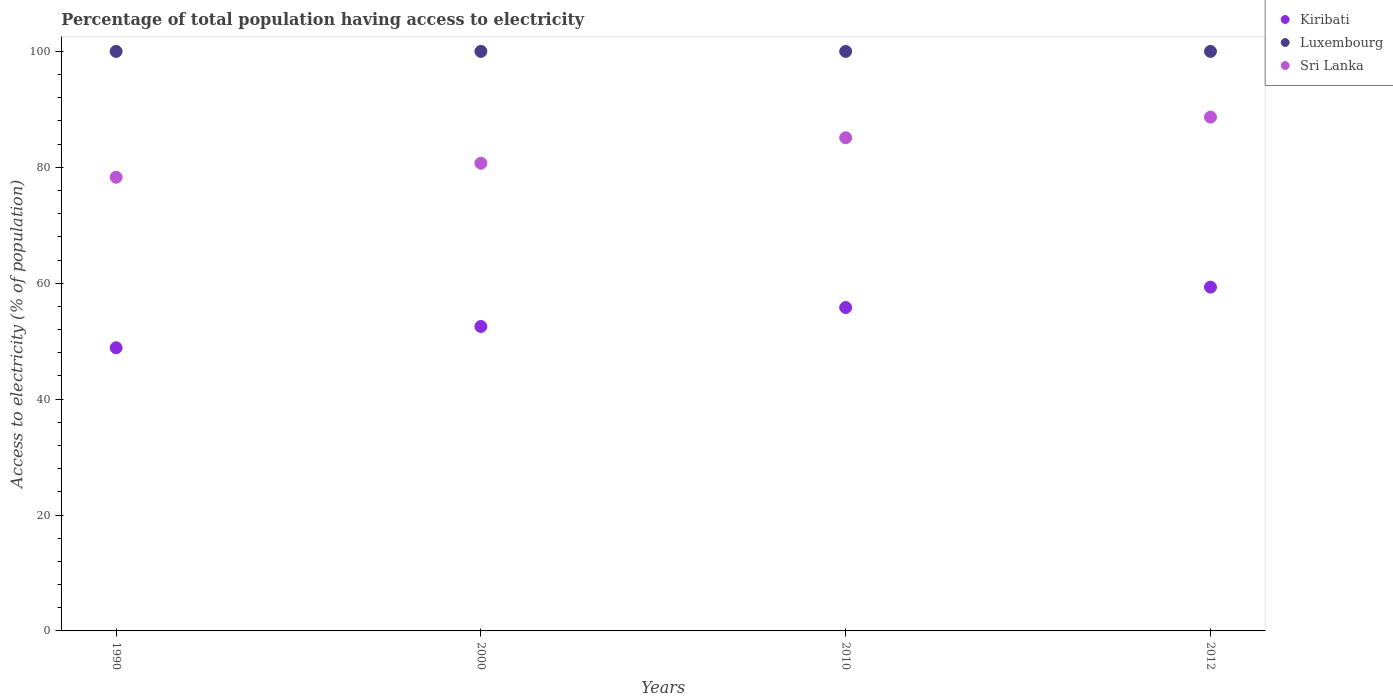What is the percentage of population that have access to electricity in Sri Lanka in 1990?
Your response must be concise. 78.29. Across all years, what is the maximum percentage of population that have access to electricity in Sri Lanka?
Provide a succinct answer. 88.66. Across all years, what is the minimum percentage of population that have access to electricity in Kiribati?
Keep it short and to the point. 48.86. In which year was the percentage of population that have access to electricity in Kiribati maximum?
Give a very brief answer. 2012. In which year was the percentage of population that have access to electricity in Sri Lanka minimum?
Ensure brevity in your answer.  1990. What is the total percentage of population that have access to electricity in Luxembourg in the graph?
Offer a very short reply. 400. What is the difference between the percentage of population that have access to electricity in Sri Lanka in 2000 and that in 2012?
Your answer should be compact. -7.96. What is the difference between the percentage of population that have access to electricity in Luxembourg in 2000 and the percentage of population that have access to electricity in Kiribati in 2010?
Make the answer very short. 44.2. In the year 2010, what is the difference between the percentage of population that have access to electricity in Sri Lanka and percentage of population that have access to electricity in Luxembourg?
Your response must be concise. -14.9. What is the ratio of the percentage of population that have access to electricity in Sri Lanka in 2000 to that in 2012?
Give a very brief answer. 0.91. Is the sum of the percentage of population that have access to electricity in Sri Lanka in 2010 and 2012 greater than the maximum percentage of population that have access to electricity in Kiribati across all years?
Provide a succinct answer. Yes. Does the percentage of population that have access to electricity in Sri Lanka monotonically increase over the years?
Provide a succinct answer. Yes. Is the percentage of population that have access to electricity in Kiribati strictly less than the percentage of population that have access to electricity in Luxembourg over the years?
Your response must be concise. Yes. How many dotlines are there?
Provide a short and direct response. 3. How many years are there in the graph?
Keep it short and to the point. 4. What is the difference between two consecutive major ticks on the Y-axis?
Give a very brief answer. 20. Where does the legend appear in the graph?
Offer a terse response. Top right. How many legend labels are there?
Your answer should be compact. 3. How are the legend labels stacked?
Provide a succinct answer. Vertical. What is the title of the graph?
Your response must be concise. Percentage of total population having access to electricity. Does "Dominica" appear as one of the legend labels in the graph?
Your answer should be compact. No. What is the label or title of the Y-axis?
Offer a terse response. Access to electricity (% of population). What is the Access to electricity (% of population) of Kiribati in 1990?
Ensure brevity in your answer.  48.86. What is the Access to electricity (% of population) of Sri Lanka in 1990?
Make the answer very short. 78.29. What is the Access to electricity (% of population) of Kiribati in 2000?
Make the answer very short. 52.53. What is the Access to electricity (% of population) in Luxembourg in 2000?
Your answer should be very brief. 100. What is the Access to electricity (% of population) in Sri Lanka in 2000?
Offer a terse response. 80.7. What is the Access to electricity (% of population) of Kiribati in 2010?
Your answer should be very brief. 55.8. What is the Access to electricity (% of population) in Luxembourg in 2010?
Your answer should be compact. 100. What is the Access to electricity (% of population) in Sri Lanka in 2010?
Give a very brief answer. 85.1. What is the Access to electricity (% of population) in Kiribati in 2012?
Ensure brevity in your answer.  59.33. What is the Access to electricity (% of population) in Luxembourg in 2012?
Your answer should be very brief. 100. What is the Access to electricity (% of population) of Sri Lanka in 2012?
Provide a short and direct response. 88.66. Across all years, what is the maximum Access to electricity (% of population) in Kiribati?
Give a very brief answer. 59.33. Across all years, what is the maximum Access to electricity (% of population) in Luxembourg?
Give a very brief answer. 100. Across all years, what is the maximum Access to electricity (% of population) in Sri Lanka?
Provide a succinct answer. 88.66. Across all years, what is the minimum Access to electricity (% of population) of Kiribati?
Your answer should be compact. 48.86. Across all years, what is the minimum Access to electricity (% of population) of Sri Lanka?
Keep it short and to the point. 78.29. What is the total Access to electricity (% of population) in Kiribati in the graph?
Make the answer very short. 216.52. What is the total Access to electricity (% of population) in Sri Lanka in the graph?
Offer a terse response. 332.75. What is the difference between the Access to electricity (% of population) in Kiribati in 1990 and that in 2000?
Your answer should be very brief. -3.67. What is the difference between the Access to electricity (% of population) in Luxembourg in 1990 and that in 2000?
Provide a succinct answer. 0. What is the difference between the Access to electricity (% of population) in Sri Lanka in 1990 and that in 2000?
Keep it short and to the point. -2.41. What is the difference between the Access to electricity (% of population) of Kiribati in 1990 and that in 2010?
Give a very brief answer. -6.94. What is the difference between the Access to electricity (% of population) of Luxembourg in 1990 and that in 2010?
Your answer should be very brief. 0. What is the difference between the Access to electricity (% of population) in Sri Lanka in 1990 and that in 2010?
Offer a very short reply. -6.81. What is the difference between the Access to electricity (% of population) in Kiribati in 1990 and that in 2012?
Your response must be concise. -10.47. What is the difference between the Access to electricity (% of population) of Luxembourg in 1990 and that in 2012?
Keep it short and to the point. 0. What is the difference between the Access to electricity (% of population) in Sri Lanka in 1990 and that in 2012?
Your answer should be very brief. -10.37. What is the difference between the Access to electricity (% of population) in Kiribati in 2000 and that in 2010?
Provide a short and direct response. -3.27. What is the difference between the Access to electricity (% of population) of Kiribati in 2000 and that in 2012?
Provide a succinct answer. -6.8. What is the difference between the Access to electricity (% of population) of Luxembourg in 2000 and that in 2012?
Your answer should be compact. 0. What is the difference between the Access to electricity (% of population) in Sri Lanka in 2000 and that in 2012?
Make the answer very short. -7.96. What is the difference between the Access to electricity (% of population) of Kiribati in 2010 and that in 2012?
Give a very brief answer. -3.53. What is the difference between the Access to electricity (% of population) of Sri Lanka in 2010 and that in 2012?
Provide a succinct answer. -3.56. What is the difference between the Access to electricity (% of population) in Kiribati in 1990 and the Access to electricity (% of population) in Luxembourg in 2000?
Give a very brief answer. -51.14. What is the difference between the Access to electricity (% of population) in Kiribati in 1990 and the Access to electricity (% of population) in Sri Lanka in 2000?
Provide a succinct answer. -31.84. What is the difference between the Access to electricity (% of population) in Luxembourg in 1990 and the Access to electricity (% of population) in Sri Lanka in 2000?
Offer a very short reply. 19.3. What is the difference between the Access to electricity (% of population) in Kiribati in 1990 and the Access to electricity (% of population) in Luxembourg in 2010?
Your response must be concise. -51.14. What is the difference between the Access to electricity (% of population) in Kiribati in 1990 and the Access to electricity (% of population) in Sri Lanka in 2010?
Your answer should be compact. -36.24. What is the difference between the Access to electricity (% of population) of Luxembourg in 1990 and the Access to electricity (% of population) of Sri Lanka in 2010?
Ensure brevity in your answer.  14.9. What is the difference between the Access to electricity (% of population) of Kiribati in 1990 and the Access to electricity (% of population) of Luxembourg in 2012?
Your response must be concise. -51.14. What is the difference between the Access to electricity (% of population) of Kiribati in 1990 and the Access to electricity (% of population) of Sri Lanka in 2012?
Give a very brief answer. -39.8. What is the difference between the Access to electricity (% of population) of Luxembourg in 1990 and the Access to electricity (% of population) of Sri Lanka in 2012?
Ensure brevity in your answer.  11.34. What is the difference between the Access to electricity (% of population) in Kiribati in 2000 and the Access to electricity (% of population) in Luxembourg in 2010?
Your answer should be compact. -47.47. What is the difference between the Access to electricity (% of population) of Kiribati in 2000 and the Access to electricity (% of population) of Sri Lanka in 2010?
Your answer should be very brief. -32.57. What is the difference between the Access to electricity (% of population) in Luxembourg in 2000 and the Access to electricity (% of population) in Sri Lanka in 2010?
Offer a very short reply. 14.9. What is the difference between the Access to electricity (% of population) in Kiribati in 2000 and the Access to electricity (% of population) in Luxembourg in 2012?
Your answer should be compact. -47.47. What is the difference between the Access to electricity (% of population) of Kiribati in 2000 and the Access to electricity (% of population) of Sri Lanka in 2012?
Offer a terse response. -36.13. What is the difference between the Access to electricity (% of population) in Luxembourg in 2000 and the Access to electricity (% of population) in Sri Lanka in 2012?
Give a very brief answer. 11.34. What is the difference between the Access to electricity (% of population) of Kiribati in 2010 and the Access to electricity (% of population) of Luxembourg in 2012?
Keep it short and to the point. -44.2. What is the difference between the Access to electricity (% of population) in Kiribati in 2010 and the Access to electricity (% of population) in Sri Lanka in 2012?
Provide a short and direct response. -32.86. What is the difference between the Access to electricity (% of population) of Luxembourg in 2010 and the Access to electricity (% of population) of Sri Lanka in 2012?
Your answer should be very brief. 11.34. What is the average Access to electricity (% of population) of Kiribati per year?
Provide a short and direct response. 54.13. What is the average Access to electricity (% of population) of Sri Lanka per year?
Your answer should be compact. 83.19. In the year 1990, what is the difference between the Access to electricity (% of population) in Kiribati and Access to electricity (% of population) in Luxembourg?
Provide a succinct answer. -51.14. In the year 1990, what is the difference between the Access to electricity (% of population) in Kiribati and Access to electricity (% of population) in Sri Lanka?
Ensure brevity in your answer.  -29.43. In the year 1990, what is the difference between the Access to electricity (% of population) in Luxembourg and Access to electricity (% of population) in Sri Lanka?
Provide a succinct answer. 21.71. In the year 2000, what is the difference between the Access to electricity (% of population) in Kiribati and Access to electricity (% of population) in Luxembourg?
Your answer should be very brief. -47.47. In the year 2000, what is the difference between the Access to electricity (% of population) in Kiribati and Access to electricity (% of population) in Sri Lanka?
Offer a terse response. -28.17. In the year 2000, what is the difference between the Access to electricity (% of population) of Luxembourg and Access to electricity (% of population) of Sri Lanka?
Keep it short and to the point. 19.3. In the year 2010, what is the difference between the Access to electricity (% of population) of Kiribati and Access to electricity (% of population) of Luxembourg?
Your response must be concise. -44.2. In the year 2010, what is the difference between the Access to electricity (% of population) in Kiribati and Access to electricity (% of population) in Sri Lanka?
Offer a very short reply. -29.3. In the year 2010, what is the difference between the Access to electricity (% of population) of Luxembourg and Access to electricity (% of population) of Sri Lanka?
Your answer should be compact. 14.9. In the year 2012, what is the difference between the Access to electricity (% of population) in Kiribati and Access to electricity (% of population) in Luxembourg?
Your answer should be compact. -40.67. In the year 2012, what is the difference between the Access to electricity (% of population) of Kiribati and Access to electricity (% of population) of Sri Lanka?
Ensure brevity in your answer.  -29.33. In the year 2012, what is the difference between the Access to electricity (% of population) of Luxembourg and Access to electricity (% of population) of Sri Lanka?
Your answer should be compact. 11.34. What is the ratio of the Access to electricity (% of population) of Kiribati in 1990 to that in 2000?
Your answer should be very brief. 0.93. What is the ratio of the Access to electricity (% of population) of Luxembourg in 1990 to that in 2000?
Keep it short and to the point. 1. What is the ratio of the Access to electricity (% of population) of Sri Lanka in 1990 to that in 2000?
Make the answer very short. 0.97. What is the ratio of the Access to electricity (% of population) in Kiribati in 1990 to that in 2010?
Ensure brevity in your answer.  0.88. What is the ratio of the Access to electricity (% of population) in Luxembourg in 1990 to that in 2010?
Make the answer very short. 1. What is the ratio of the Access to electricity (% of population) of Sri Lanka in 1990 to that in 2010?
Your response must be concise. 0.92. What is the ratio of the Access to electricity (% of population) in Kiribati in 1990 to that in 2012?
Provide a succinct answer. 0.82. What is the ratio of the Access to electricity (% of population) in Sri Lanka in 1990 to that in 2012?
Your answer should be very brief. 0.88. What is the ratio of the Access to electricity (% of population) of Kiribati in 2000 to that in 2010?
Your answer should be very brief. 0.94. What is the ratio of the Access to electricity (% of population) in Sri Lanka in 2000 to that in 2010?
Provide a short and direct response. 0.95. What is the ratio of the Access to electricity (% of population) of Kiribati in 2000 to that in 2012?
Your answer should be compact. 0.89. What is the ratio of the Access to electricity (% of population) in Sri Lanka in 2000 to that in 2012?
Provide a short and direct response. 0.91. What is the ratio of the Access to electricity (% of population) of Kiribati in 2010 to that in 2012?
Your answer should be very brief. 0.94. What is the ratio of the Access to electricity (% of population) of Luxembourg in 2010 to that in 2012?
Offer a terse response. 1. What is the ratio of the Access to electricity (% of population) in Sri Lanka in 2010 to that in 2012?
Keep it short and to the point. 0.96. What is the difference between the highest and the second highest Access to electricity (% of population) in Kiribati?
Provide a succinct answer. 3.53. What is the difference between the highest and the second highest Access to electricity (% of population) of Luxembourg?
Offer a very short reply. 0. What is the difference between the highest and the second highest Access to electricity (% of population) in Sri Lanka?
Give a very brief answer. 3.56. What is the difference between the highest and the lowest Access to electricity (% of population) in Kiribati?
Give a very brief answer. 10.47. What is the difference between the highest and the lowest Access to electricity (% of population) in Sri Lanka?
Your response must be concise. 10.37. 